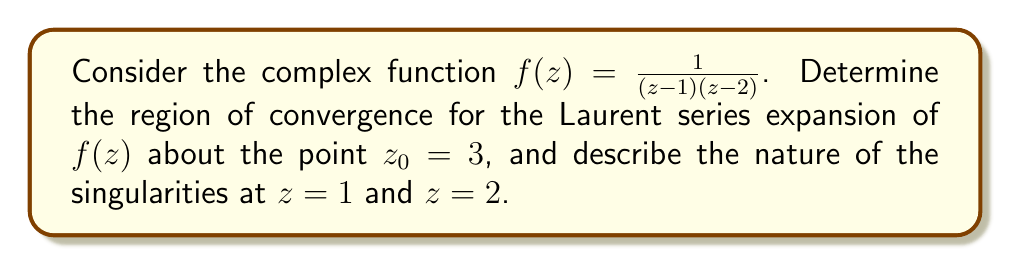What is the answer to this math problem? To determine the region of convergence for the Laurent series expansion of $f(z)$ about $z_0 = 3$, we need to follow these steps:

1) First, let's rewrite the function in partial fractions:

   $$f(z) = \frac{1}{(z-1)(z-2)} = \frac{A}{z-1} + \frac{B}{z-2}$$

   where $A = \frac{1}{1-2} = -1$ and $B = \frac{1}{2-1} = 1$

   So, $f(z) = \frac{-1}{z-1} + \frac{1}{z-2}$

2) Now, we need to expand each term about $z_0 = 3$:

   For $\frac{-1}{z-1}$:
   $$\frac{-1}{z-1} = \frac{-1}{(z-3)+2} = -\frac{1}{2} \cdot \frac{1}{1-(\frac{3-z}{2})} = -\frac{1}{2} \sum_{n=0}^{\infty} \left(\frac{3-z}{2}\right)^n$$

   For $\frac{1}{z-2}$:
   $$\frac{1}{z-2} = \frac{1}{(z-3)+1} = \frac{1}{1-(3-z)} = \sum_{n=0}^{\infty} (3-z)^n$$

3) The Laurent series expansion is the sum of these two series:

   $$f(z) = -\frac{1}{2} \sum_{n=0}^{\infty} \left(\frac{3-z}{2}\right)^n + \sum_{n=0}^{\infty} (3-z)^n$$

4) For this series to converge, we need both component series to converge. The geometric series $\sum_{n=0}^{\infty} r^n$ converges when $|r| < 1$.

   For the first series: $\left|\frac{3-z}{2}\right| < 1$, which implies $1 < |z-3| < 3$
   For the second series: $|3-z| < 1$, which implies $|z-3| < 1$

5) The region of convergence is the intersection of these two regions, which is $|z-3| < 1$.

6) Regarding the singularities:
   - At $z = 1$, we have a simple pole (order 1) because the function has a factor of $(z-1)$ in the denominator.
   - At $z = 2$, we also have a simple pole (order 1) for the same reason.

   Both are isolated singularities.
Answer: The Laurent series expansion of $f(z) = \frac{1}{(z-1)(z-2)}$ about $z_0 = 3$ converges in the region $|z-3| < 1$. The function has simple poles at $z = 1$ and $z = 2$. 